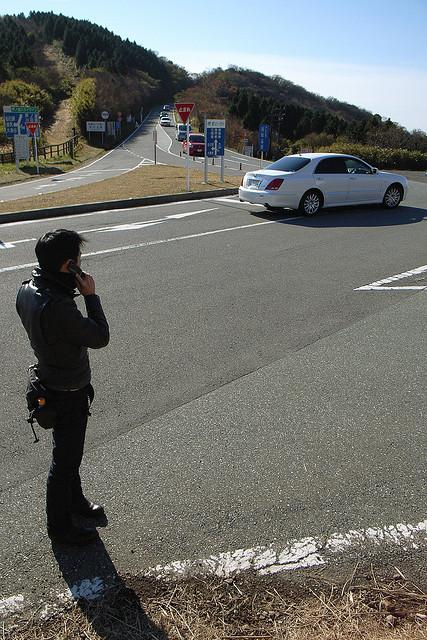What shape is the red sign?

Choices:
A) rhombus
B) sphere
C) triangular
D) circular triangular 